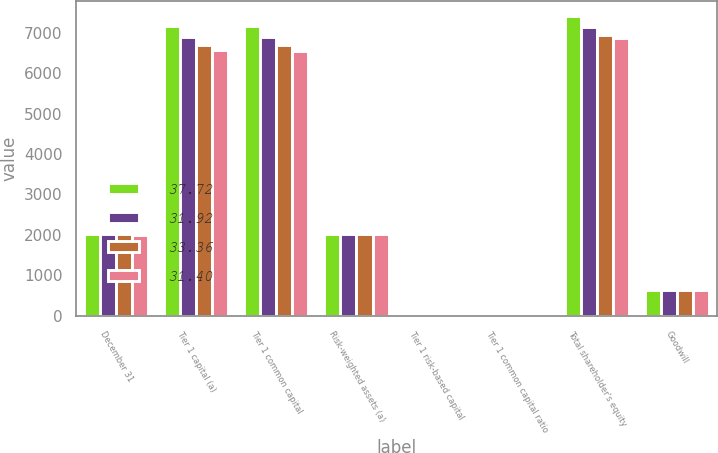Convert chart. <chart><loc_0><loc_0><loc_500><loc_500><stacked_bar_chart><ecel><fcel>December 31<fcel>Tier 1 capital (a)<fcel>Tier 1 common capital<fcel>Risk-weighted assets (a)<fcel>Tier 1 risk-based capital<fcel>Tier 1 common capital ratio<fcel>Total shareholder's equity<fcel>Goodwill<nl><fcel>37.72<fcel>2014<fcel>7169<fcel>7169<fcel>2012.5<fcel>10.5<fcel>10.5<fcel>7402<fcel>635<nl><fcel>31.92<fcel>2013<fcel>6895<fcel>6895<fcel>2012.5<fcel>10.64<fcel>10.64<fcel>7150<fcel>635<nl><fcel>33.36<fcel>2012<fcel>6705<fcel>6705<fcel>2012.5<fcel>10.14<fcel>10.14<fcel>6939<fcel>635<nl><fcel>31.4<fcel>2011<fcel>6582<fcel>6557<fcel>2012.5<fcel>10.41<fcel>10.37<fcel>6865<fcel>635<nl></chart> 